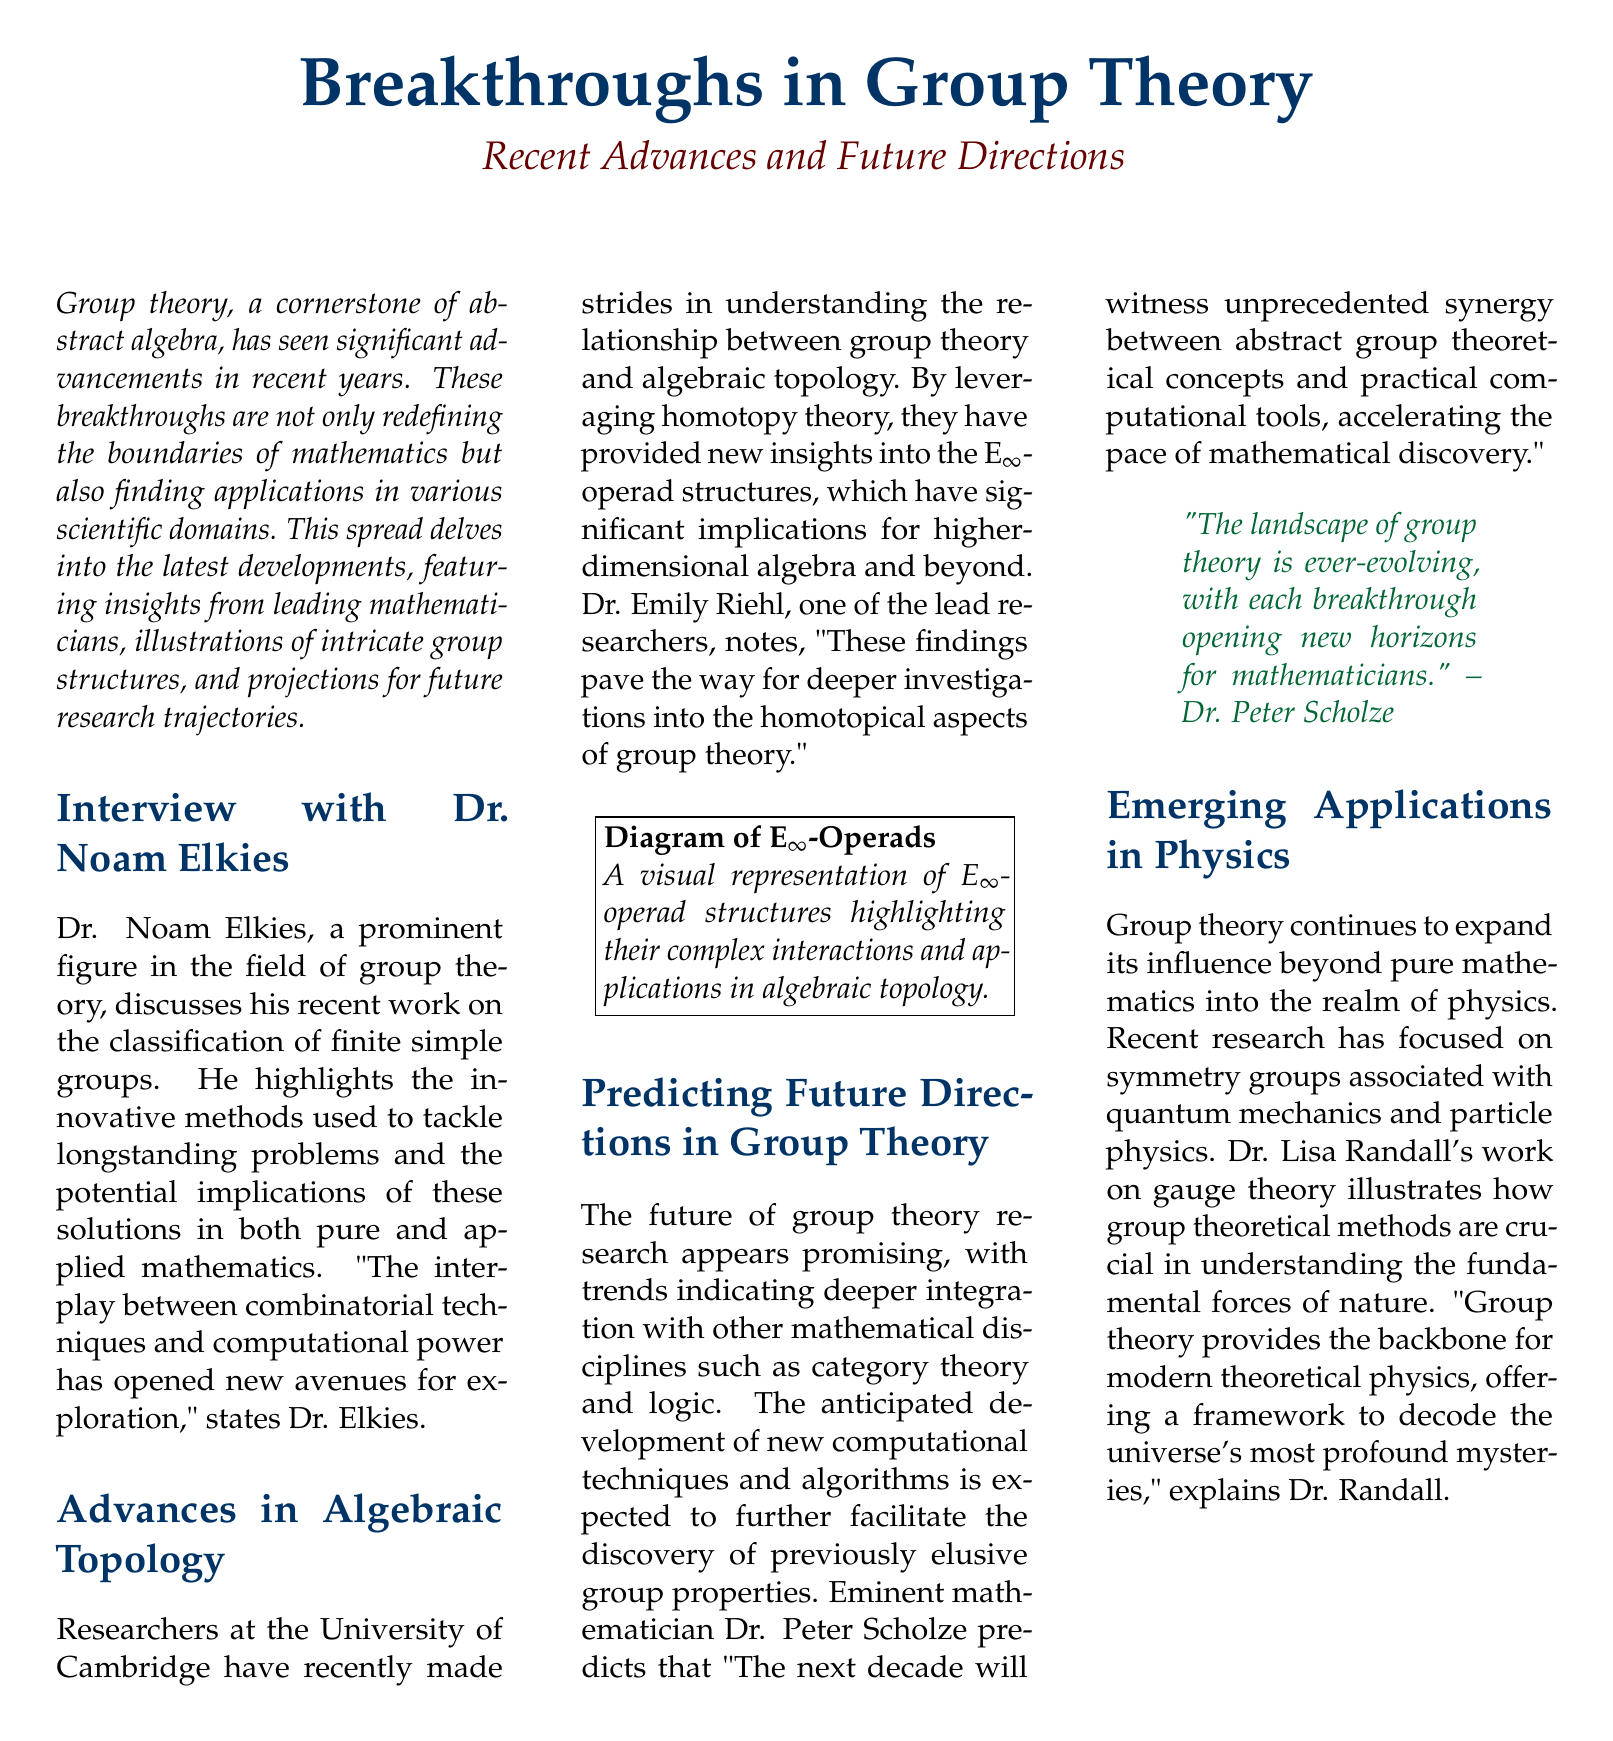What is the title of the document? The title of the document is prominently displayed at the top, summarizing its main topic.
Answer: Breakthroughs in Group Theory Who is the leading mathematician interviewed in the document? The interview section reveals the name of the prominent figure in group theory discussing breakthroughs in the field.
Answer: Dr. Noam Elkies What significant theory has been explored at the University of Cambridge? The document mentions recent advancements related to a particular mathematical theory, highlighting the focus of research efforts.
Answer: Algebraic Topology Which visual representation is included in the document? The document describes a diagram meant to illustrate complex structures relevant to the discussed theories.
Answer: E$_\infty$-Operads What does Dr. Peter Scholze predict for the next decade in group theory? This question pertains to a forward-looking statement made by a renowned mathematician regarding future advancements in the field.
Answer: Unprecedented synergy Which applications of group theory are highlighted in the document? The document discusses areas where group theory is applied beyond pure mathematics, specifically in another scientific field.
Answer: Physics What mathematical method is crucial according to Dr. Lisa Randall? The document cites a specific theoretical approach emphasized by Dr. Randall relating to physics and group theory's role in it.
Answer: Gauge theory 